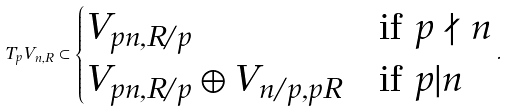<formula> <loc_0><loc_0><loc_500><loc_500>T _ { p } V _ { n , R } \subset \begin{cases} V _ { p n , R / p } & \text {if $p \nmid n$} \\ V _ { p n , R / p } \oplus V _ { n / p , p R } & \text {if $p | n$} \end{cases} .</formula> 